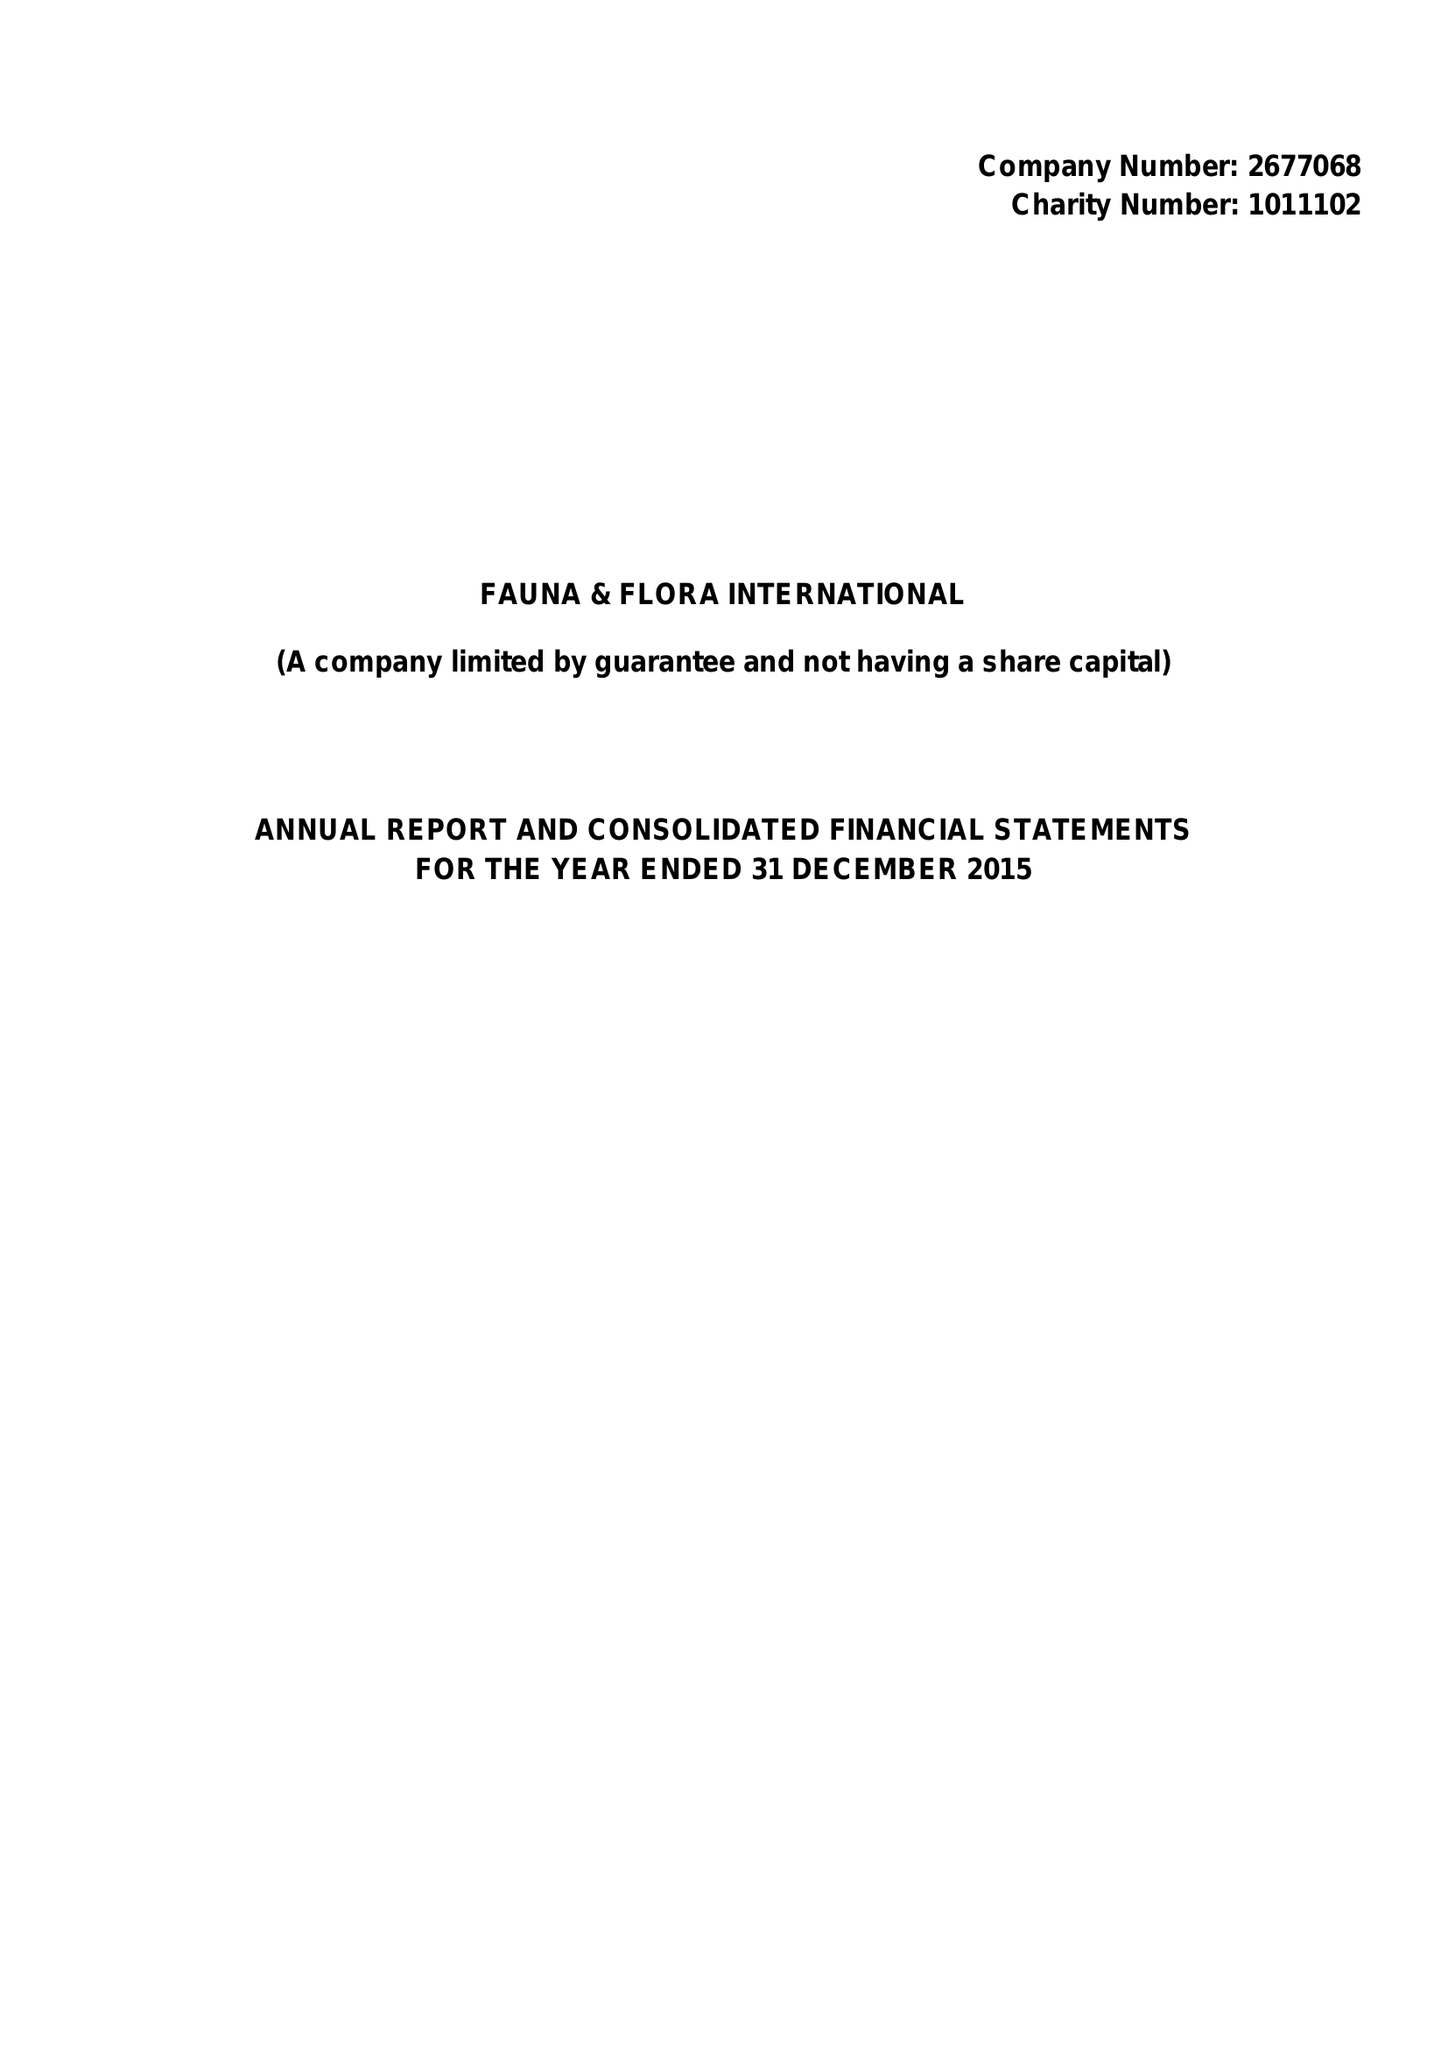What is the value for the report_date?
Answer the question using a single word or phrase. 2015-12-31 